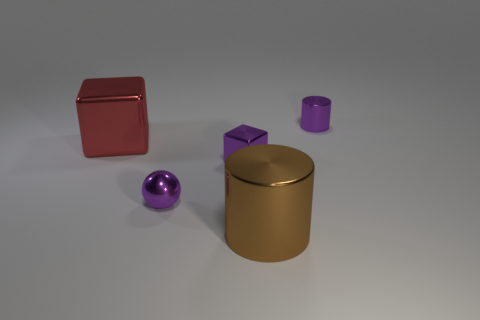Subtract all brown cylinders. How many cylinders are left? 1 Add 5 balls. How many objects exist? 10 Subtract all large brown shiny cylinders. Subtract all small shiny cubes. How many objects are left? 3 Add 2 purple cubes. How many purple cubes are left? 3 Add 3 big blocks. How many big blocks exist? 4 Subtract 0 gray cylinders. How many objects are left? 5 Subtract all balls. How many objects are left? 4 Subtract 1 cylinders. How many cylinders are left? 1 Subtract all yellow cylinders. Subtract all purple balls. How many cylinders are left? 2 Subtract all yellow cylinders. How many red blocks are left? 1 